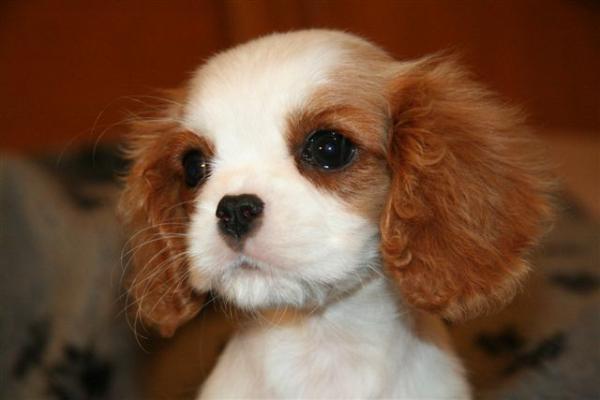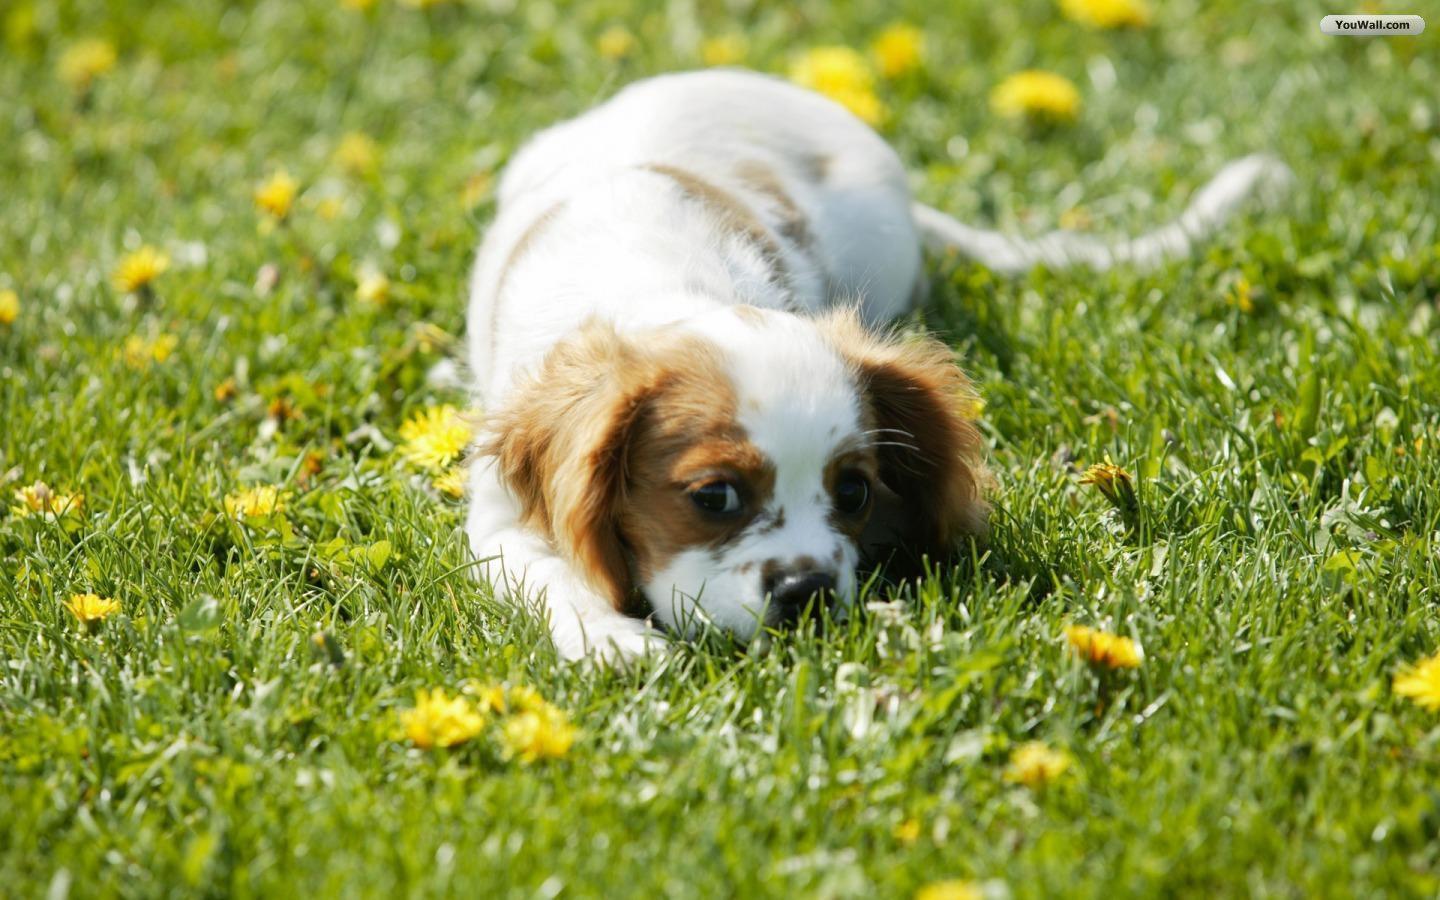The first image is the image on the left, the second image is the image on the right. Considering the images on both sides, is "Right image shows a brown and white spaniel on the grass." valid? Answer yes or no. Yes. The first image is the image on the left, the second image is the image on the right. Given the left and right images, does the statement "One of the images shows a dog that is standing." hold true? Answer yes or no. No. 